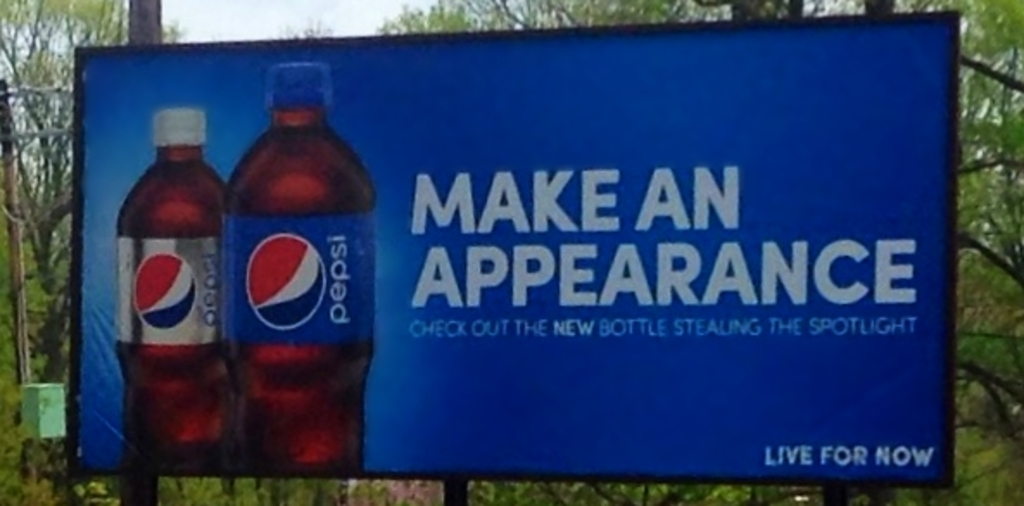What do you see happening in this image? The image captures a vibrant billboard advertisement for Pepsi located alongside a road, noticeable from its bright blue backdrop decorated with sharp white text. It features two bottles of Pepsi, one maintaining the classic design and the other highlighting a newer, more modern look. The advertisement's text, 'Make an appearance' alongside 'Check out the new bottle stealing the spotlight,' creates a dynamic interplay, urging onlookers to notice the latest design changes. Additionally, Pepsi's enduring slogan, 'Live for now,' is portrayed at the bottom, encouraging viewers to embrace the moment with Pepsi. The setting includes lush greenery in the background, subtly emphasizing the freshness linked with the beverage. 